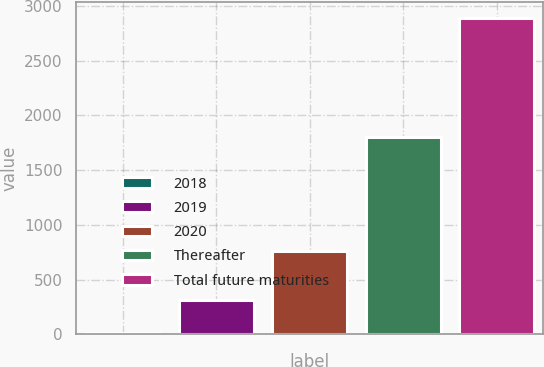Convert chart to OTSL. <chart><loc_0><loc_0><loc_500><loc_500><bar_chart><fcel>2018<fcel>2019<fcel>2020<fcel>Thereafter<fcel>Total future maturities<nl><fcel>13<fcel>314<fcel>761<fcel>1800<fcel>2888<nl></chart> 